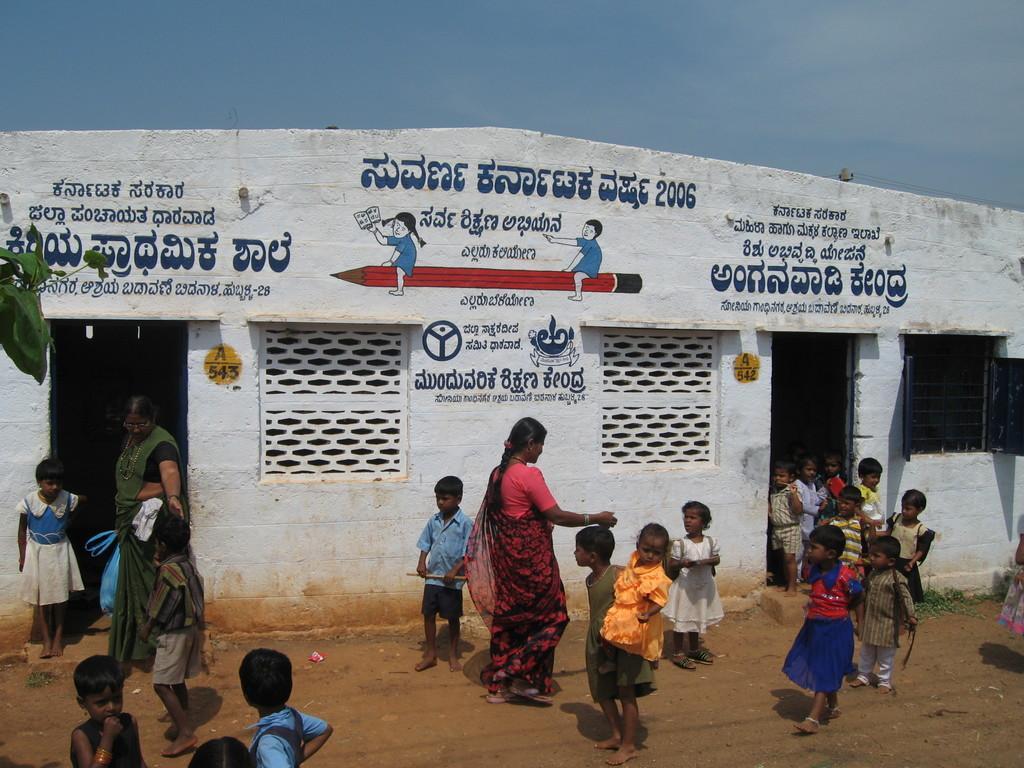How would you summarize this image in a sentence or two? In this picture, we see children are coming out of the room. We see a woman in red saree is walking. Beside them, we see a building in white color. We see some text written in different language. This building might be a school. At the top of the picture, we see the sky. On the right side, we see a window. 